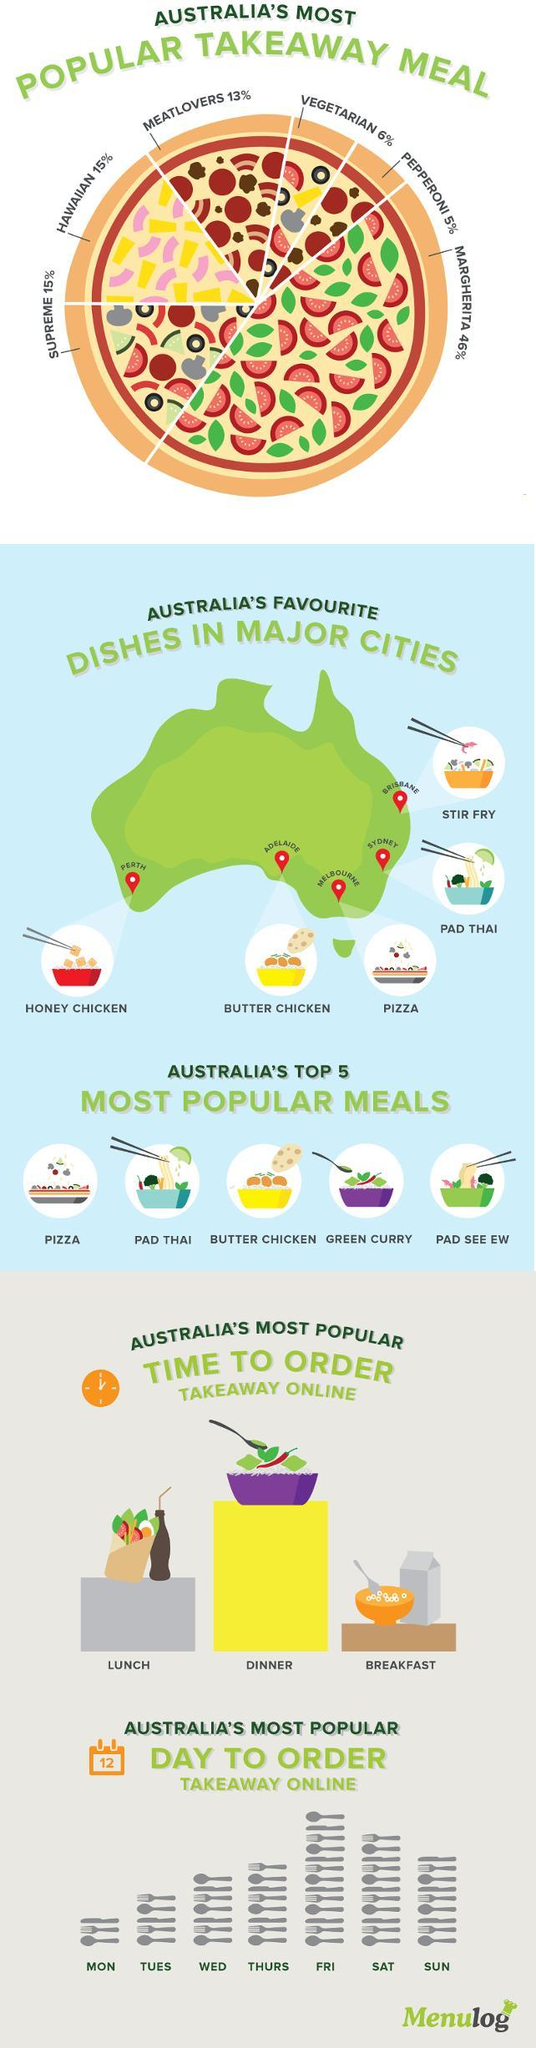How many spoons are shown above WED?
Answer the question with a short phrase. 3 What time do most people order takeaway food online? DINNER How many spoons, forks and knives are shown under most popular day to order? 54 Which day is Australia's most popular day to order takeaway online? FRI What percent of people like vegetarian and Hawaiian pizza? 21% Which dish is favourite of those in Adelaide? BUTTER CHICKEN 